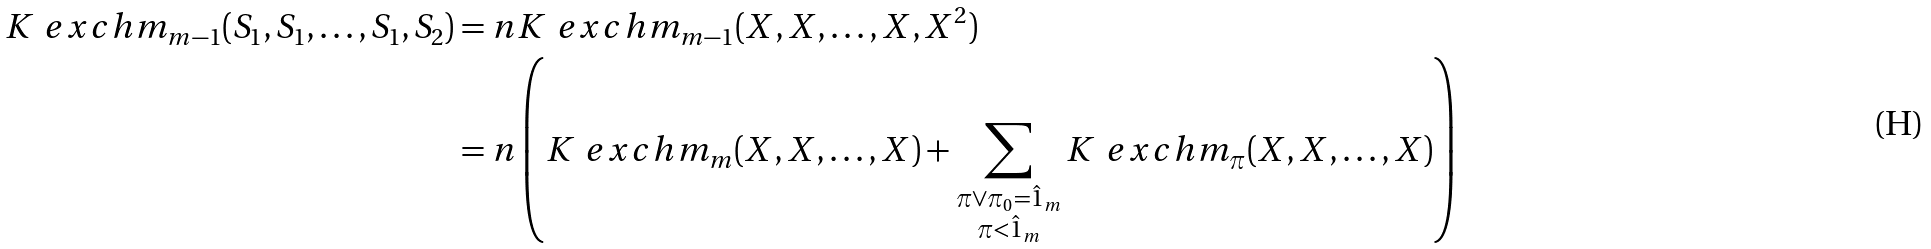<formula> <loc_0><loc_0><loc_500><loc_500>K ^ { \ } e x c h m _ { m - 1 } ( S _ { 1 } , S _ { 1 } , \dots , S _ { 1 } , S _ { 2 } ) & = n K ^ { \ } e x c h m _ { m - 1 } ( X , X , \dots , X , X ^ { 2 } ) \\ & = n \left ( K ^ { \ } e x c h m _ { m } ( X , X , \dots , X ) + \sum _ { \substack { \pi \vee \pi _ { 0 } = \hat { 1 } _ { m } \\ \pi < \hat { 1 } _ { m } } } K ^ { \ } e x c h m _ { \pi } ( X , X , \dots , X ) \right )</formula> 